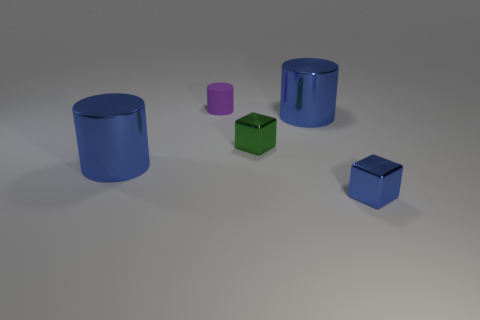There is a object that is both behind the small green cube and right of the tiny cylinder; what shape is it?
Provide a succinct answer. Cylinder. Is the size of the metal cube that is behind the small blue shiny thing the same as the blue thing that is to the left of the small purple thing?
Your answer should be very brief. No. Is the small green thing the same shape as the tiny purple matte object?
Your response must be concise. No. Is the blue cube the same size as the purple rubber object?
Make the answer very short. Yes. There is a blue cube that is the same material as the tiny green block; what size is it?
Offer a very short reply. Small. How many tiny rubber things are the same color as the tiny cylinder?
Your answer should be compact. 0. Are there fewer small cylinders that are on the right side of the tiny blue shiny thing than blue metallic objects behind the small green metallic object?
Keep it short and to the point. Yes. Do the object on the left side of the small matte cylinder and the small blue metallic object have the same shape?
Keep it short and to the point. No. Is there anything else that is made of the same material as the green block?
Offer a very short reply. Yes. Is the material of the block on the right side of the tiny green shiny block the same as the tiny purple object?
Offer a terse response. No. 